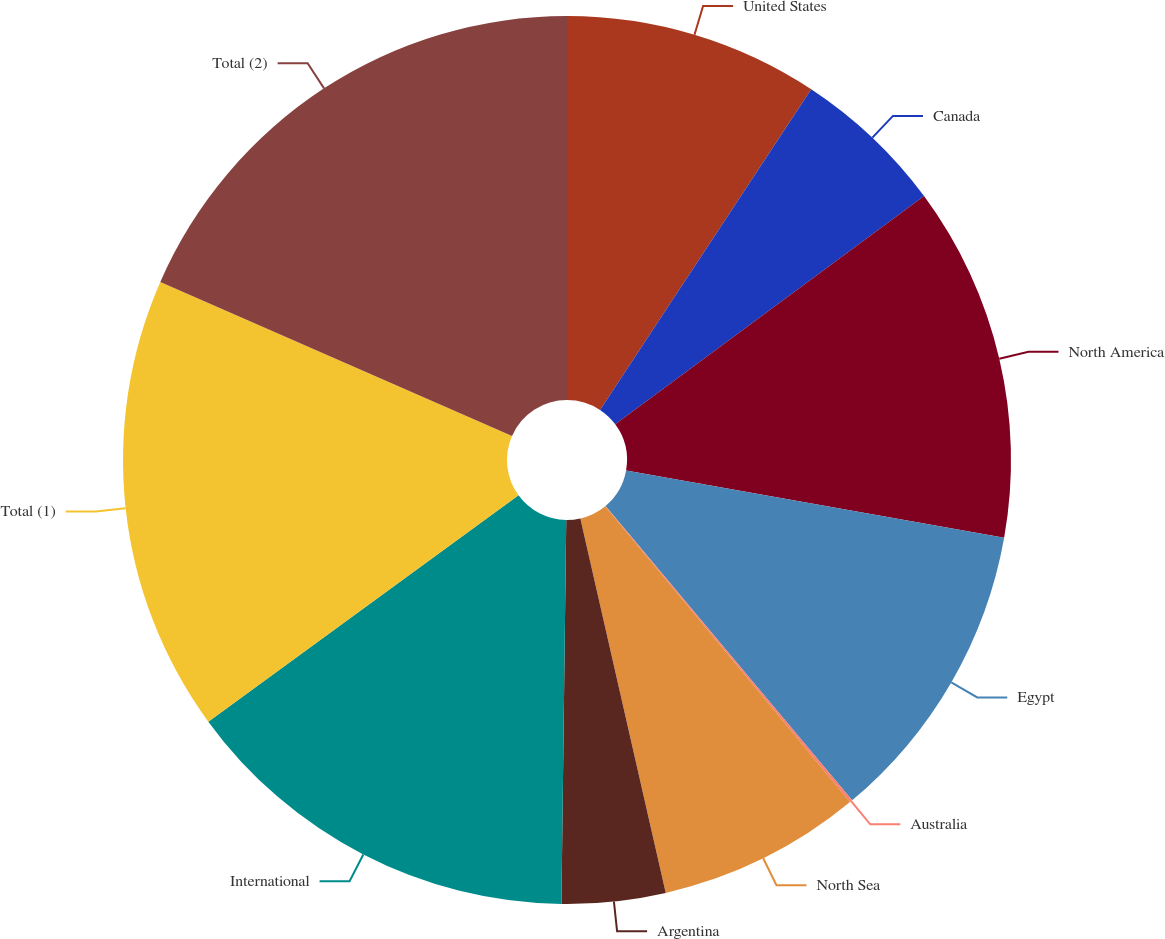Convert chart. <chart><loc_0><loc_0><loc_500><loc_500><pie_chart><fcel>United States<fcel>Canada<fcel>North America<fcel>Egypt<fcel>Australia<fcel>North Sea<fcel>Argentina<fcel>International<fcel>Total (1)<fcel>Total (2)<nl><fcel>9.27%<fcel>5.6%<fcel>12.93%<fcel>11.1%<fcel>0.1%<fcel>7.43%<fcel>3.77%<fcel>14.77%<fcel>16.6%<fcel>18.43%<nl></chart> 